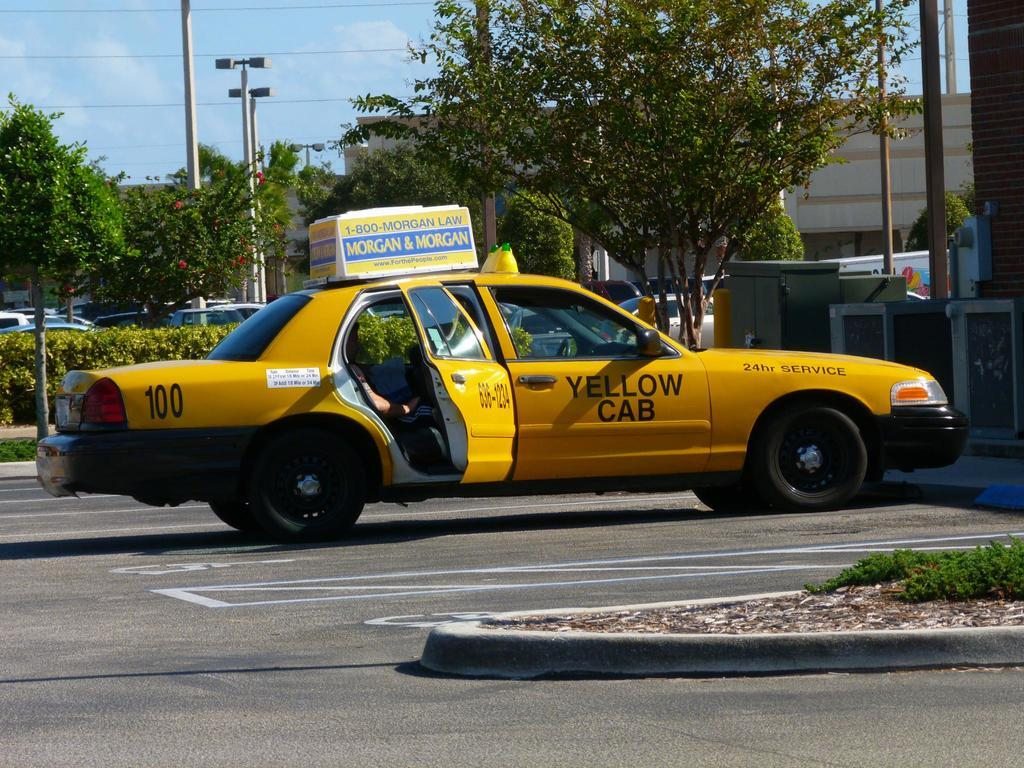<image>
Offer a succinct explanation of the picture presented. A parked yellow cab with the back passenger side door open. 